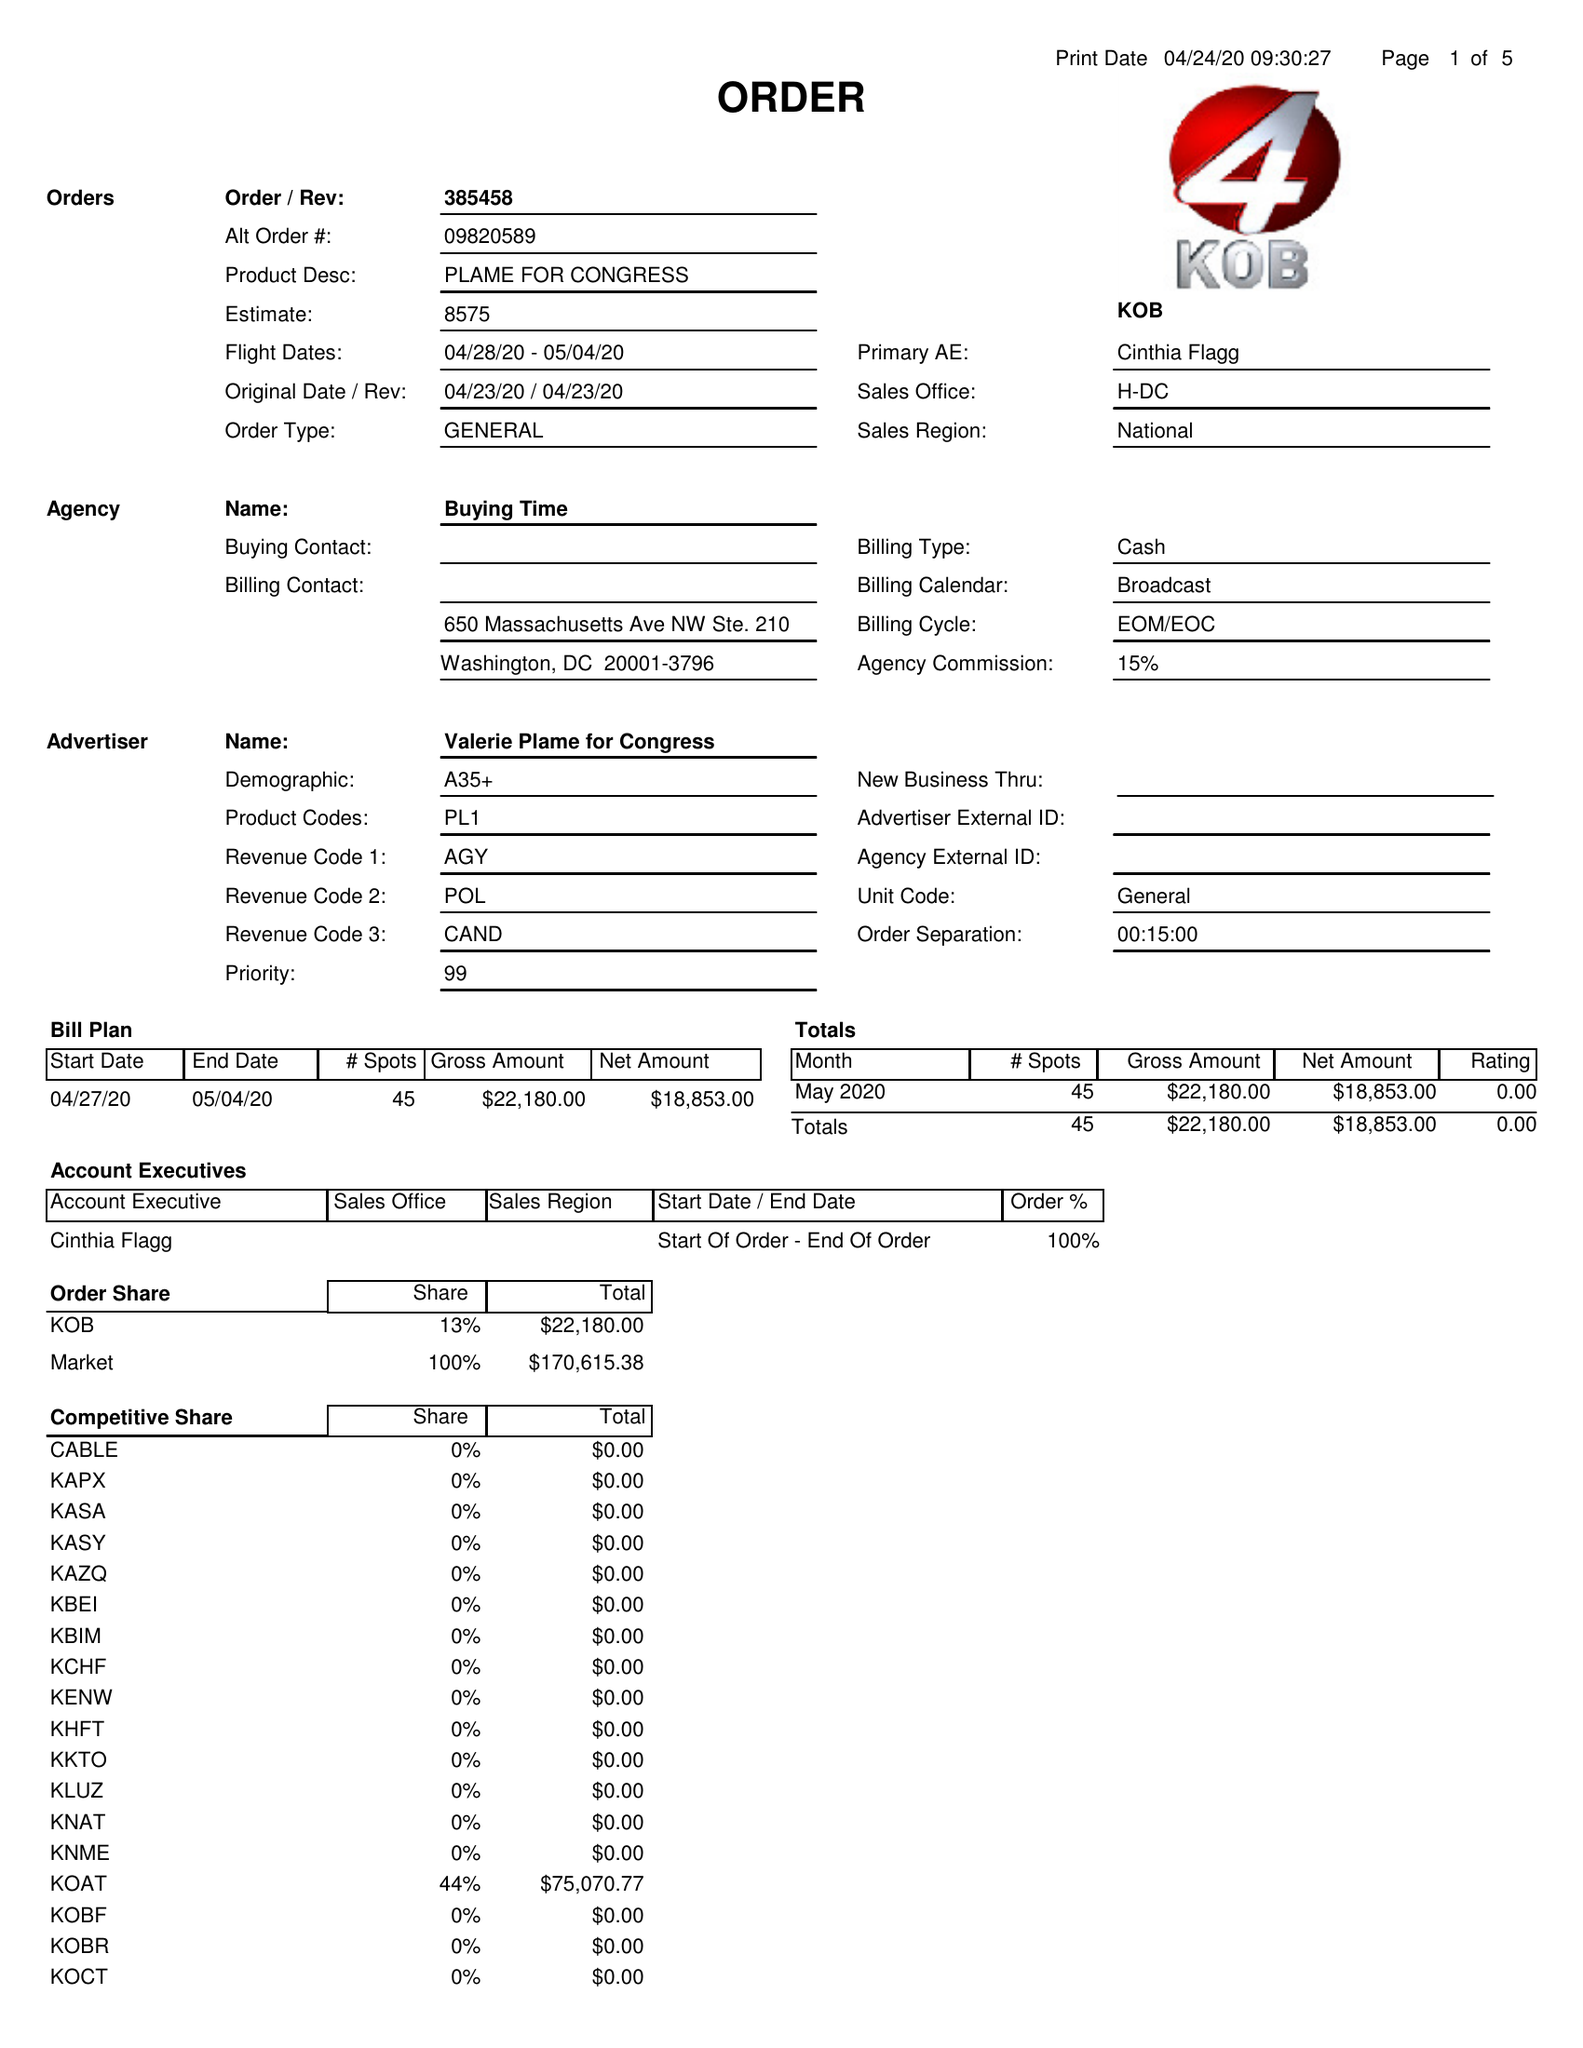What is the value for the flight_to?
Answer the question using a single word or phrase. 05/04/20 